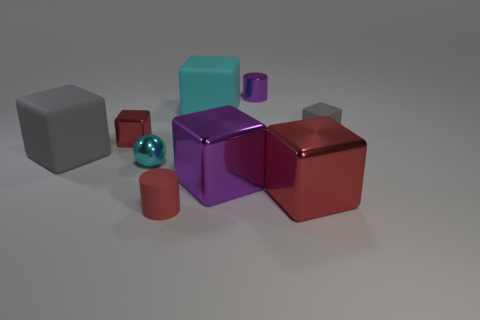How many tiny objects are cyan rubber blocks or red rubber cylinders? In the image, there is one cyan rubber block and one red rubber cylinder, making a total of two tiny objects that fit the description. 